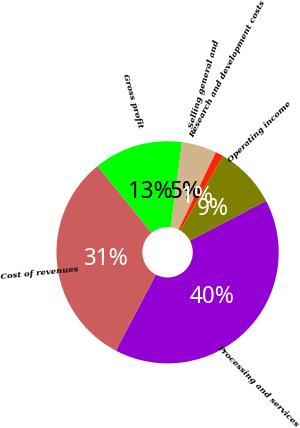Convert chart. <chart><loc_0><loc_0><loc_500><loc_500><pie_chart><fcel>Processing and services<fcel>Cost of revenues<fcel>Gross profit<fcel>Selling general and<fcel>Research and development costs<fcel>Operating income<nl><fcel>40.38%<fcel>31.44%<fcel>12.93%<fcel>5.09%<fcel>1.16%<fcel>9.01%<nl></chart> 